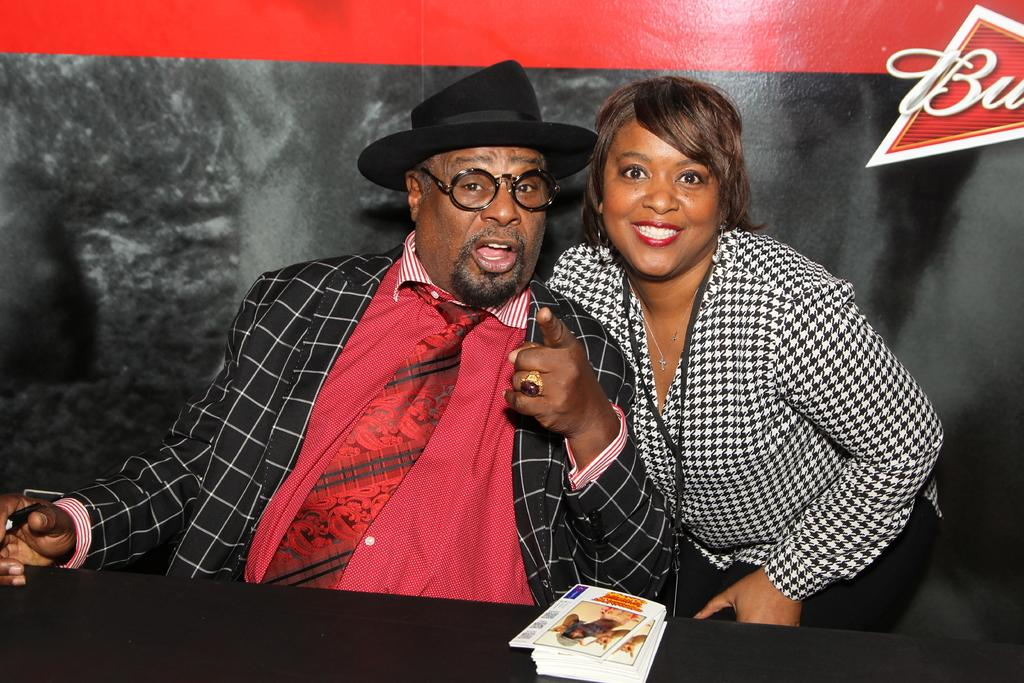How many people are in the image? There are two people in the image, a man and a woman. What is the man wearing on his face? The man is wearing spectacles. What type of headwear is the man wearing? The man is wearing a cap. What can be seen on the table or desk in the image? There are papers visible in the image. What is located at the top right corner of the image? There is a logo at the top right corner of the image. What memory does the woman recall in the image? There is no indication in the image that the woman is recalling a memory. What type of debt is the man discussing in the image? There is no mention of debt in the image. 